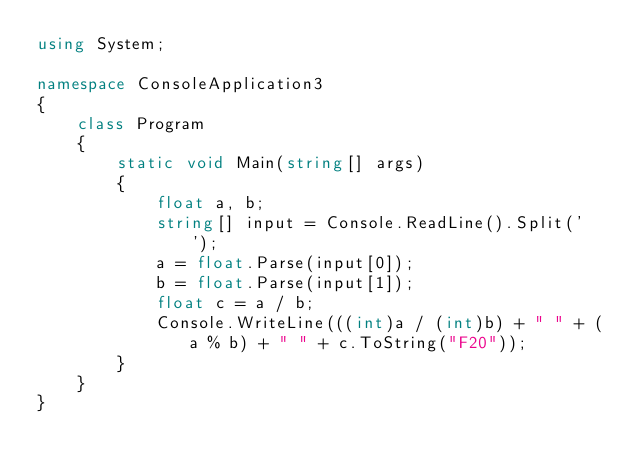<code> <loc_0><loc_0><loc_500><loc_500><_C#_>using System;

namespace ConsoleApplication3
{
    class Program
    {
        static void Main(string[] args)
        {
            float a, b;
            string[] input = Console.ReadLine().Split(' ');
            a = float.Parse(input[0]);
            b = float.Parse(input[1]);
            float c = a / b;
            Console.WriteLine(((int)a / (int)b) + " " + (a % b) + " " + c.ToString("F20"));
        }
    }
}</code> 